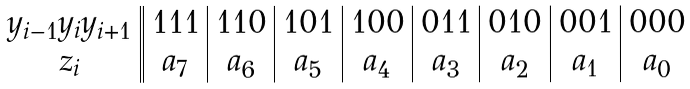<formula> <loc_0><loc_0><loc_500><loc_500>\begin{array} { c | | c | c | c | c | c | c | c | c } y _ { i - 1 } y _ { i } y _ { i + 1 } & 1 1 1 & 1 1 0 & 1 0 1 & 1 0 0 & 0 1 1 & 0 1 0 & 0 0 1 & 0 0 0 \\ z _ { i } & a _ { 7 } & a _ { 6 } & a _ { 5 } & a _ { 4 } & a _ { 3 } & a _ { 2 } & a _ { 1 } & a _ { 0 } \end{array}</formula> 